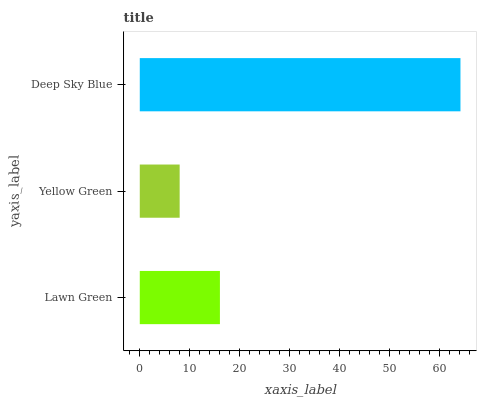Is Yellow Green the minimum?
Answer yes or no. Yes. Is Deep Sky Blue the maximum?
Answer yes or no. Yes. Is Deep Sky Blue the minimum?
Answer yes or no. No. Is Yellow Green the maximum?
Answer yes or no. No. Is Deep Sky Blue greater than Yellow Green?
Answer yes or no. Yes. Is Yellow Green less than Deep Sky Blue?
Answer yes or no. Yes. Is Yellow Green greater than Deep Sky Blue?
Answer yes or no. No. Is Deep Sky Blue less than Yellow Green?
Answer yes or no. No. Is Lawn Green the high median?
Answer yes or no. Yes. Is Lawn Green the low median?
Answer yes or no. Yes. Is Yellow Green the high median?
Answer yes or no. No. Is Deep Sky Blue the low median?
Answer yes or no. No. 